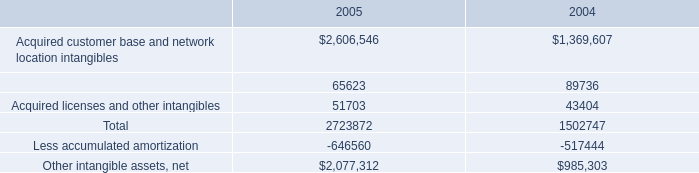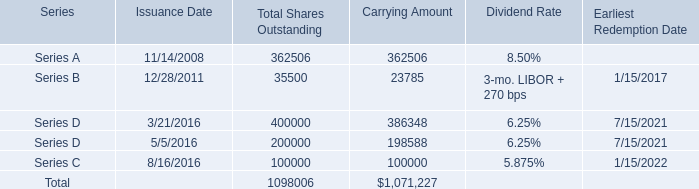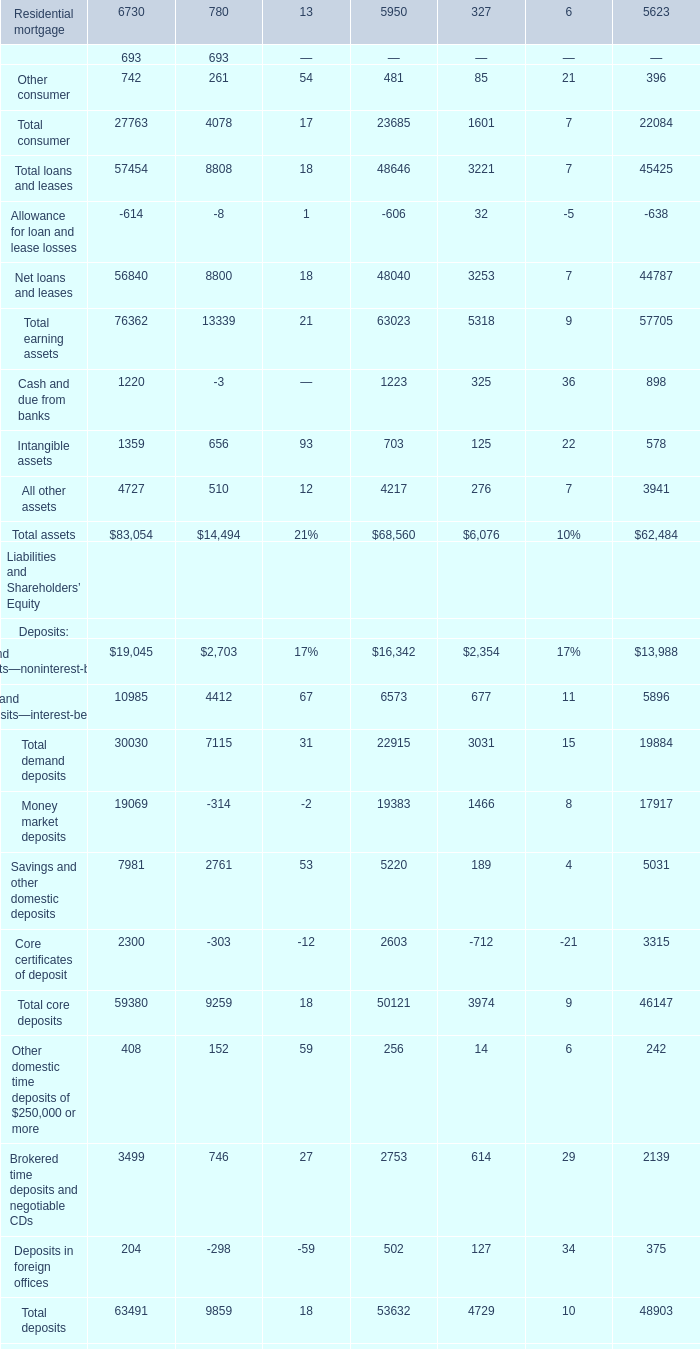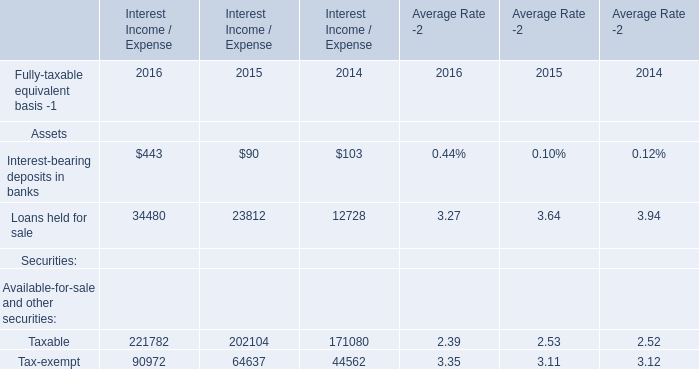assuming that intangible asset will be sold , what will be the accumulated deprecation at the end of 2006 , in millions? 
Computations: ((646560 / 1000) + 183.6)
Answer: 830.16. 